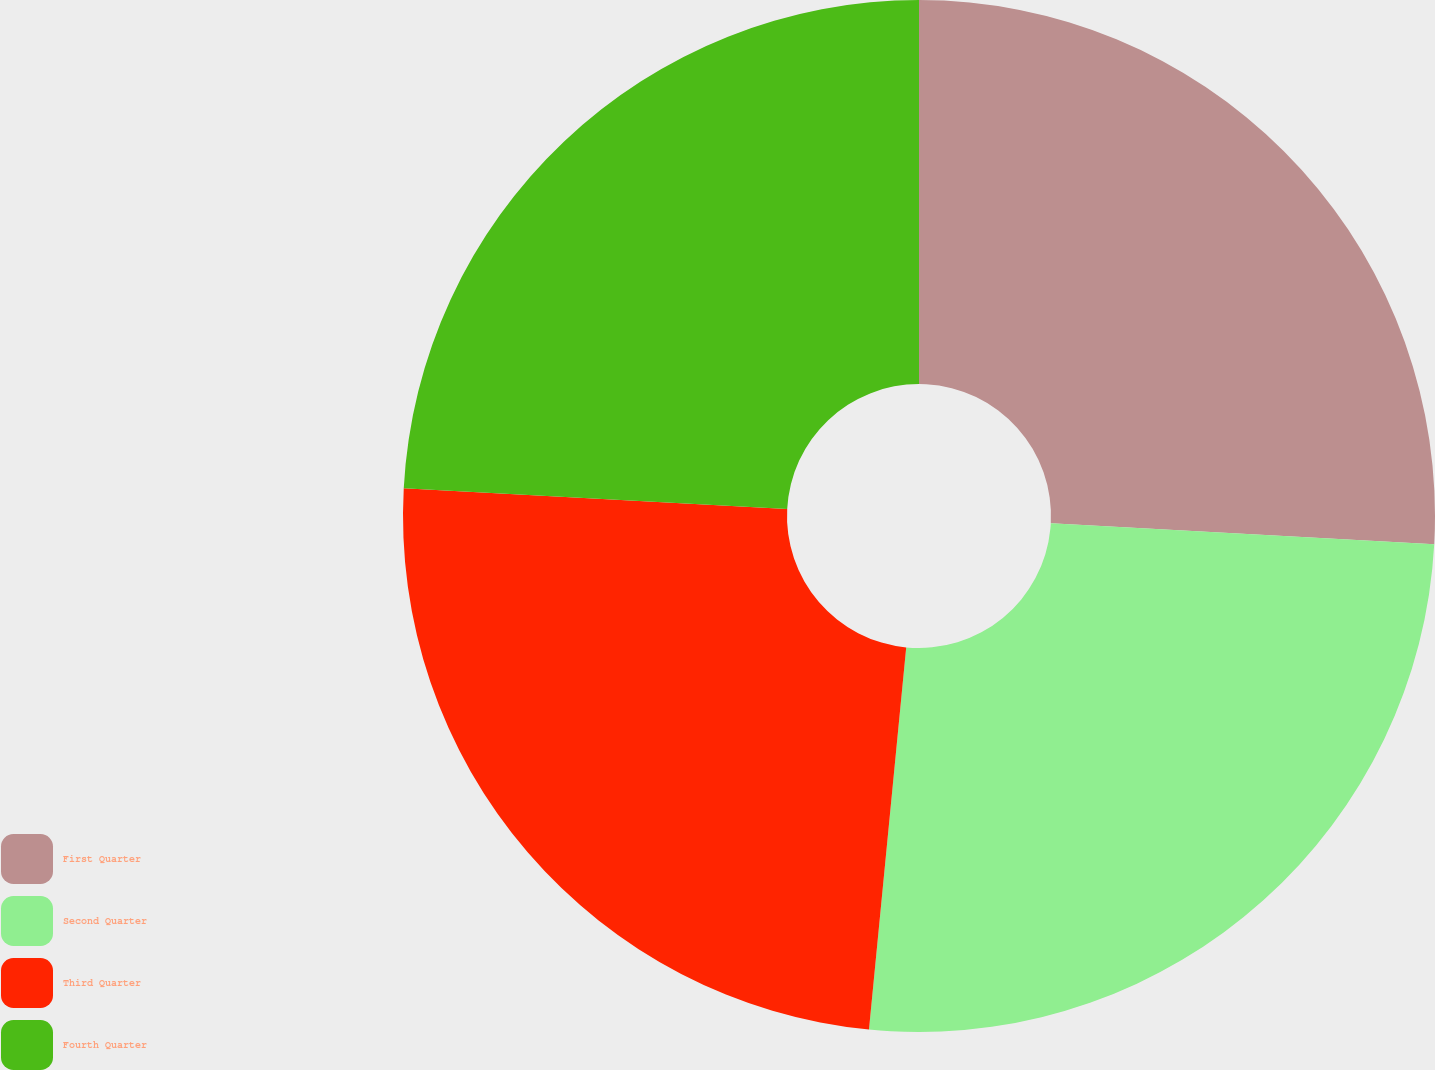Convert chart. <chart><loc_0><loc_0><loc_500><loc_500><pie_chart><fcel>First Quarter<fcel>Second Quarter<fcel>Third Quarter<fcel>Fourth Quarter<nl><fcel>25.87%<fcel>25.67%<fcel>24.31%<fcel>24.14%<nl></chart> 